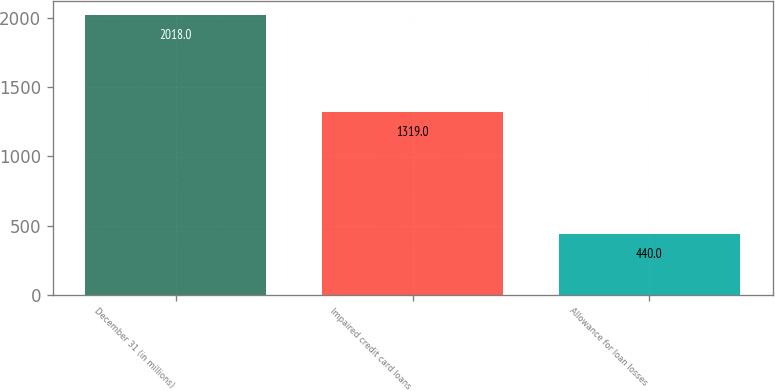<chart> <loc_0><loc_0><loc_500><loc_500><bar_chart><fcel>December 31 (in millions)<fcel>Impaired credit card loans<fcel>Allowance for loan losses<nl><fcel>2018<fcel>1319<fcel>440<nl></chart> 